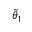<formula> <loc_0><loc_0><loc_500><loc_500>\tilde { \theta } _ { 1 }</formula> 